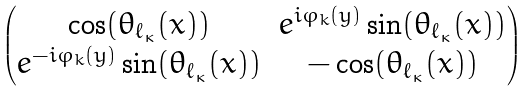<formula> <loc_0><loc_0><loc_500><loc_500>\begin{pmatrix} \cos ( \theta _ { \ell _ { \kappa } } ( x ) ) & e ^ { i \varphi _ { k } ( y ) } \sin ( \theta _ { \ell _ { \kappa } } ( x ) ) \\ e ^ { - i \varphi _ { k } ( y ) } \sin ( \theta _ { \ell _ { \kappa } } ( x ) ) & - \cos ( \theta _ { \ell _ { \kappa } } ( x ) ) \end{pmatrix}</formula> 